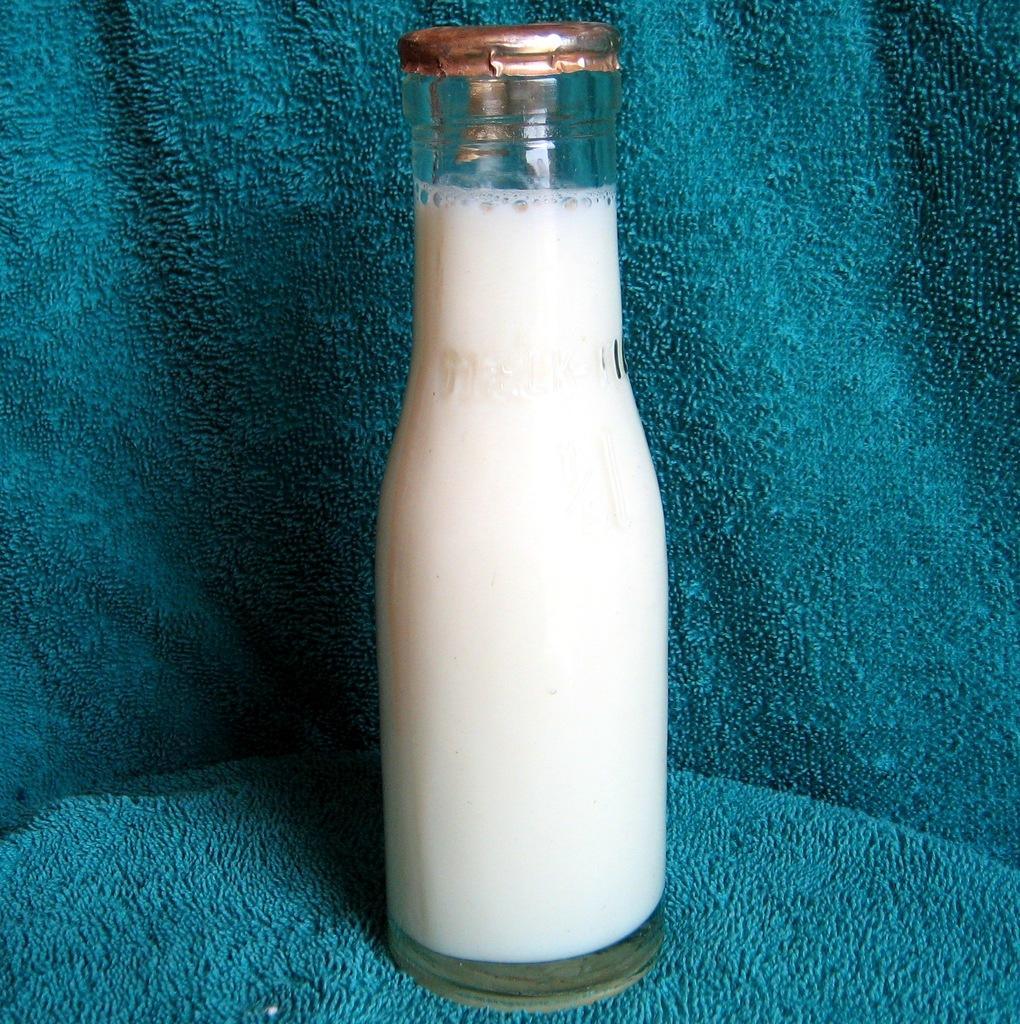Could you give a brief overview of what you see in this image? In the center of the image there is a milk bottle on the blue cloth. 